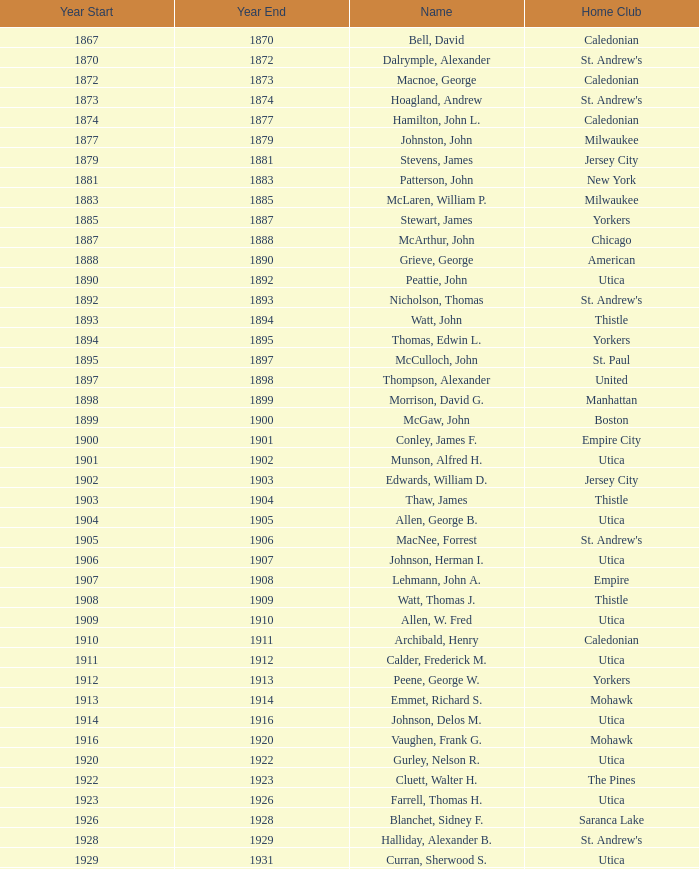Which Number has a Year Start smaller than 1874, and a Year End larger than 1873? 4.0. 